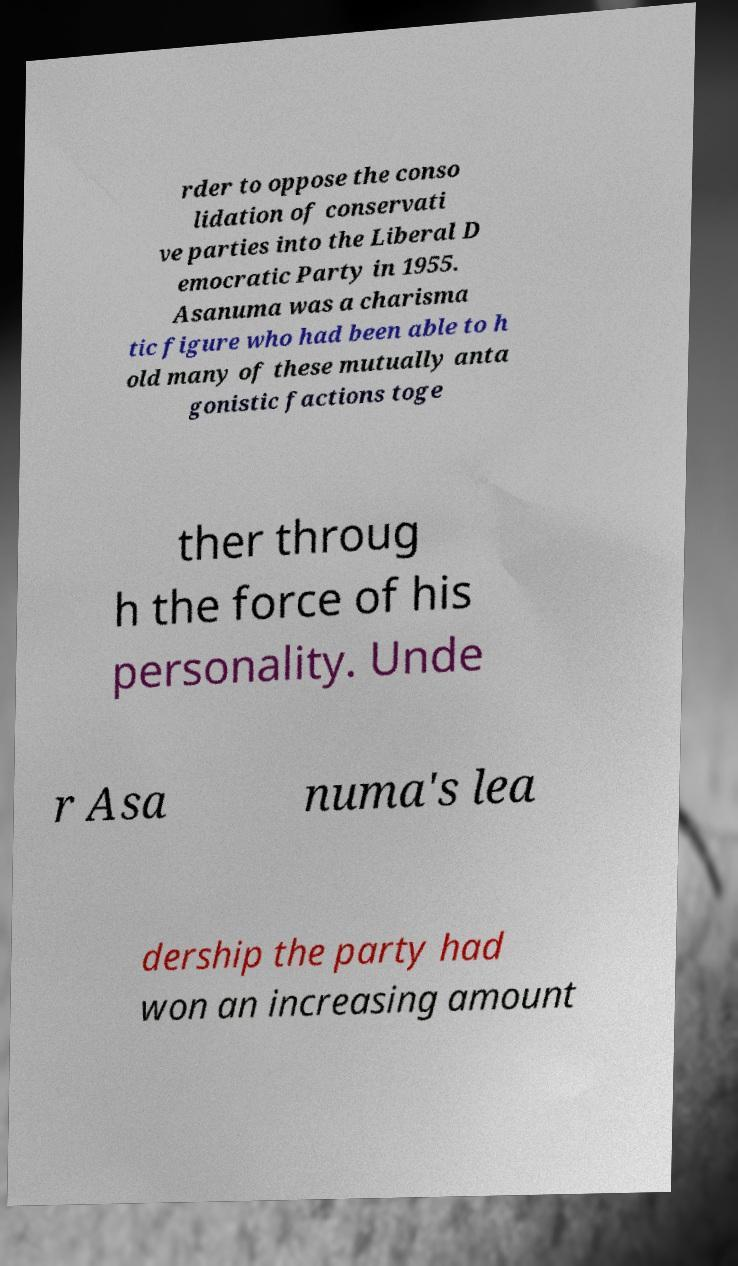Could you extract and type out the text from this image? rder to oppose the conso lidation of conservati ve parties into the Liberal D emocratic Party in 1955. Asanuma was a charisma tic figure who had been able to h old many of these mutually anta gonistic factions toge ther throug h the force of his personality. Unde r Asa numa's lea dership the party had won an increasing amount 